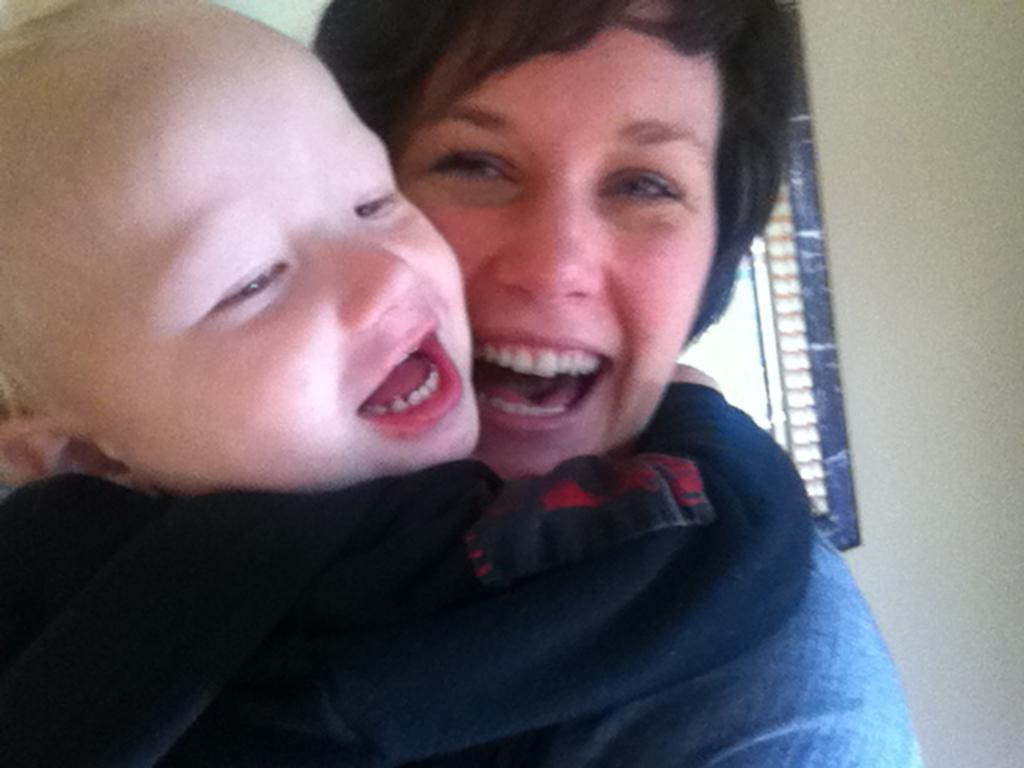Who is the main subject in the image? There is a woman in the image. What is the woman doing in the image? The woman is carrying a baby. How are the woman and the baby feeling in the image? Both the woman and the baby are smiling. What can be seen in the background of the image? There is a window visible in the background of the image. What flavor of ice cream is the baby tasting in the image? There is no ice cream present in the image, so it cannot be determined if the baby is tasting any flavor. 